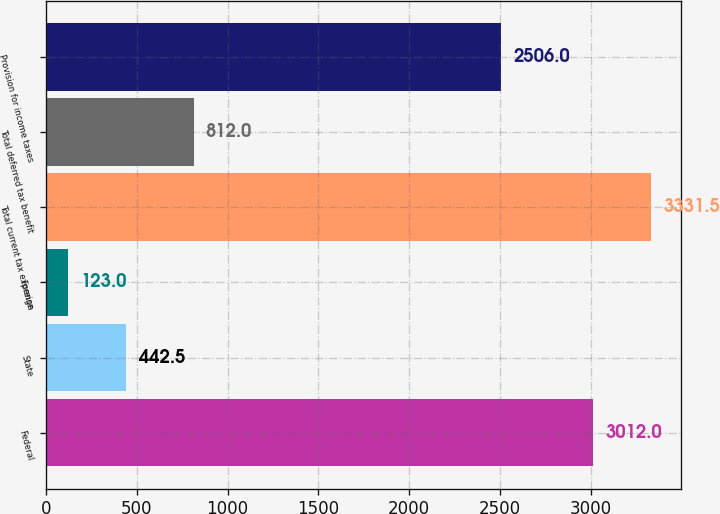Convert chart to OTSL. <chart><loc_0><loc_0><loc_500><loc_500><bar_chart><fcel>Federal<fcel>State<fcel>Foreign<fcel>Total current tax expense<fcel>Total deferred tax benefit<fcel>Provision for income taxes<nl><fcel>3012<fcel>442.5<fcel>123<fcel>3331.5<fcel>812<fcel>2506<nl></chart> 